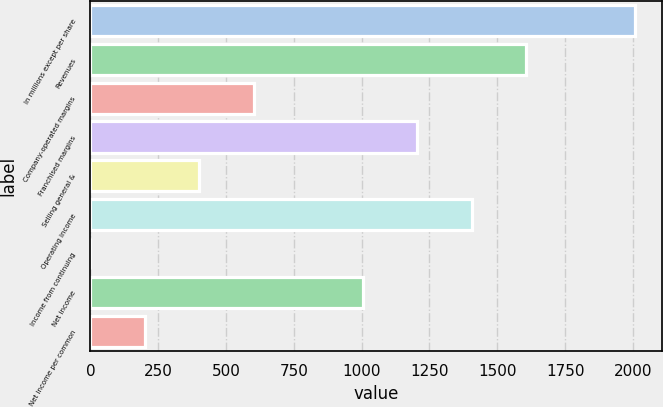Convert chart to OTSL. <chart><loc_0><loc_0><loc_500><loc_500><bar_chart><fcel>In millions except per share<fcel>Revenues<fcel>Company-operated margins<fcel>Franchised margins<fcel>Selling general &<fcel>Operating income<fcel>Income from continuing<fcel>Net income<fcel>Net income per common<nl><fcel>2008<fcel>1606.41<fcel>602.46<fcel>1204.83<fcel>401.67<fcel>1405.62<fcel>0.09<fcel>1004.04<fcel>200.88<nl></chart> 